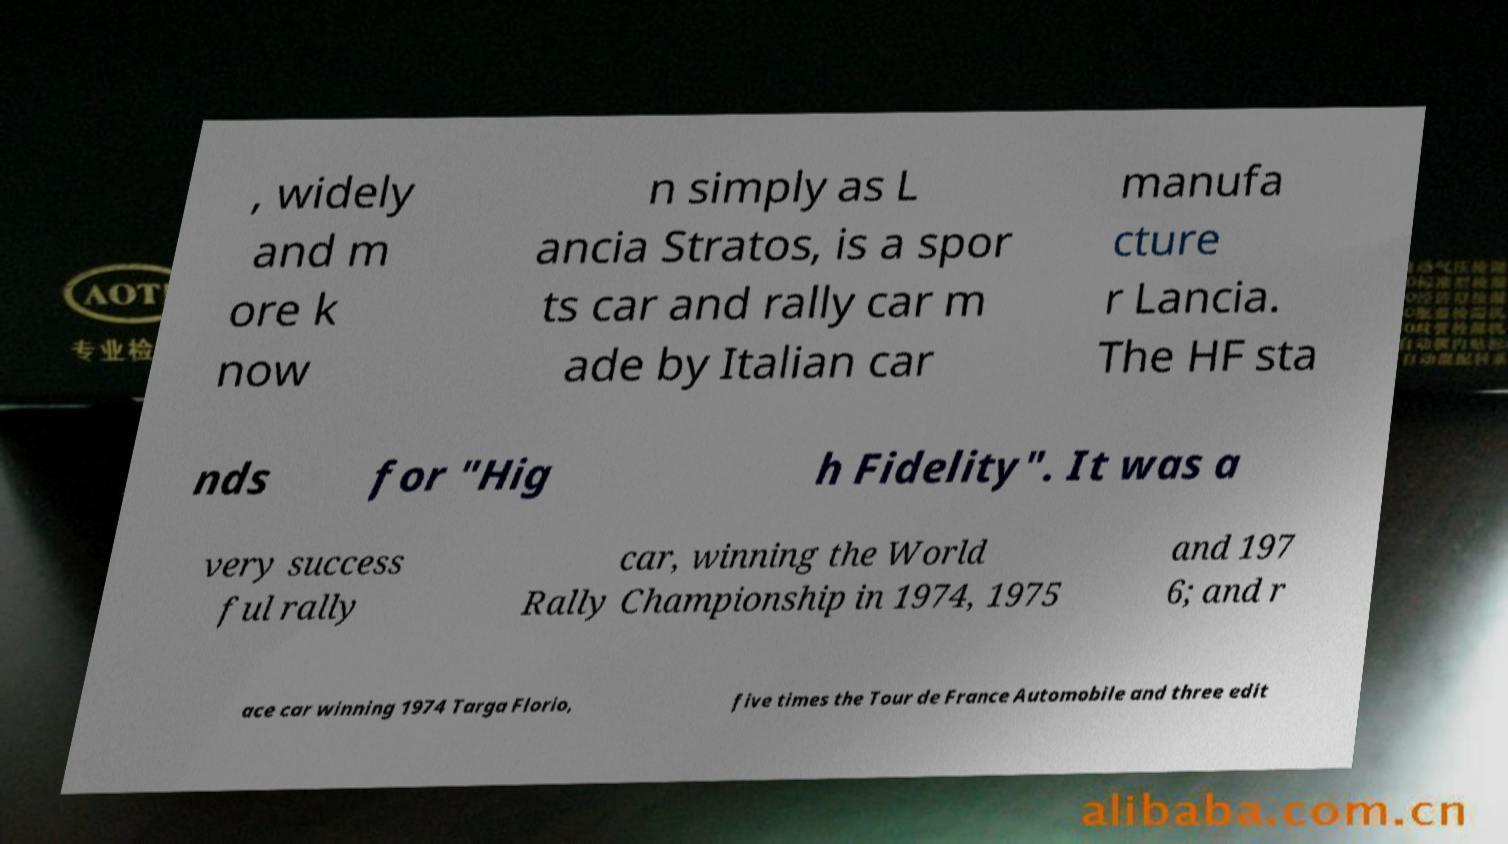For documentation purposes, I need the text within this image transcribed. Could you provide that? , widely and m ore k now n simply as L ancia Stratos, is a spor ts car and rally car m ade by Italian car manufa cture r Lancia. The HF sta nds for "Hig h Fidelity". It was a very success ful rally car, winning the World Rally Championship in 1974, 1975 and 197 6; and r ace car winning 1974 Targa Florio, five times the Tour de France Automobile and three edit 